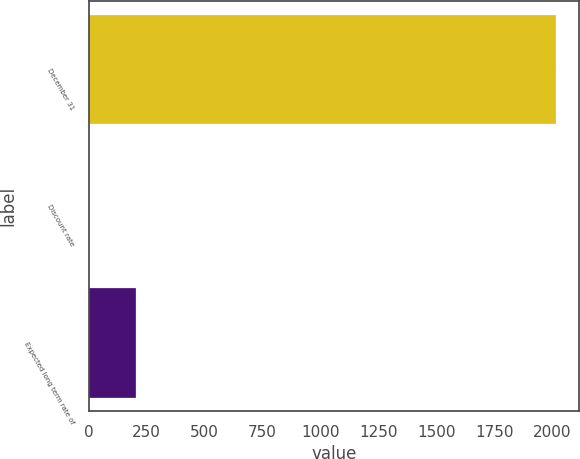<chart> <loc_0><loc_0><loc_500><loc_500><bar_chart><fcel>December 31<fcel>Discount rate<fcel>Expected long term rate of<nl><fcel>2015<fcel>4<fcel>205.1<nl></chart> 